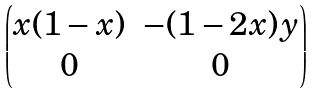<formula> <loc_0><loc_0><loc_500><loc_500>\begin{pmatrix} x ( 1 - x ) & - ( 1 - 2 x ) y \\ 0 & 0 \end{pmatrix}</formula> 